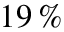<formula> <loc_0><loc_0><loc_500><loc_500>1 9 \, \%</formula> 